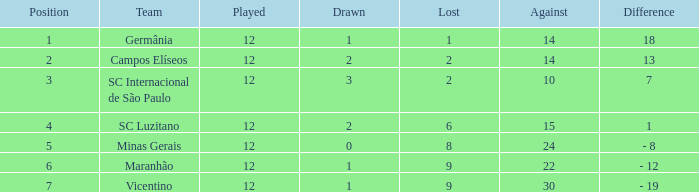What is the combined number of drawn matches where a player has participated more than 12 times? 0.0. Parse the table in full. {'header': ['Position', 'Team', 'Played', 'Drawn', 'Lost', 'Against', 'Difference'], 'rows': [['1', 'Germânia', '12', '1', '1', '14', '18'], ['2', 'Campos Elíseos', '12', '2', '2', '14', '13'], ['3', 'SC Internacional de São Paulo', '12', '3', '2', '10', '7'], ['4', 'SC Luzitano', '12', '2', '6', '15', '1'], ['5', 'Minas Gerais', '12', '0', '8', '24', '- 8'], ['6', 'Maranhão', '12', '1', '9', '22', '- 12'], ['7', 'Vicentino', '12', '1', '9', '30', '- 19']]} 